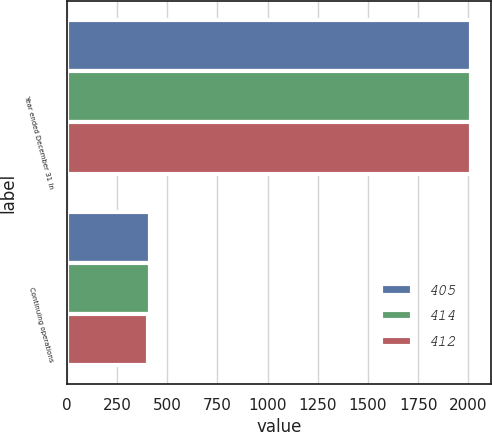<chart> <loc_0><loc_0><loc_500><loc_500><stacked_bar_chart><ecel><fcel>Year ended December 31 In<fcel>Continuing operations<nl><fcel>405<fcel>2014<fcel>414<nl><fcel>414<fcel>2013<fcel>412<nl><fcel>412<fcel>2012<fcel>405<nl></chart> 